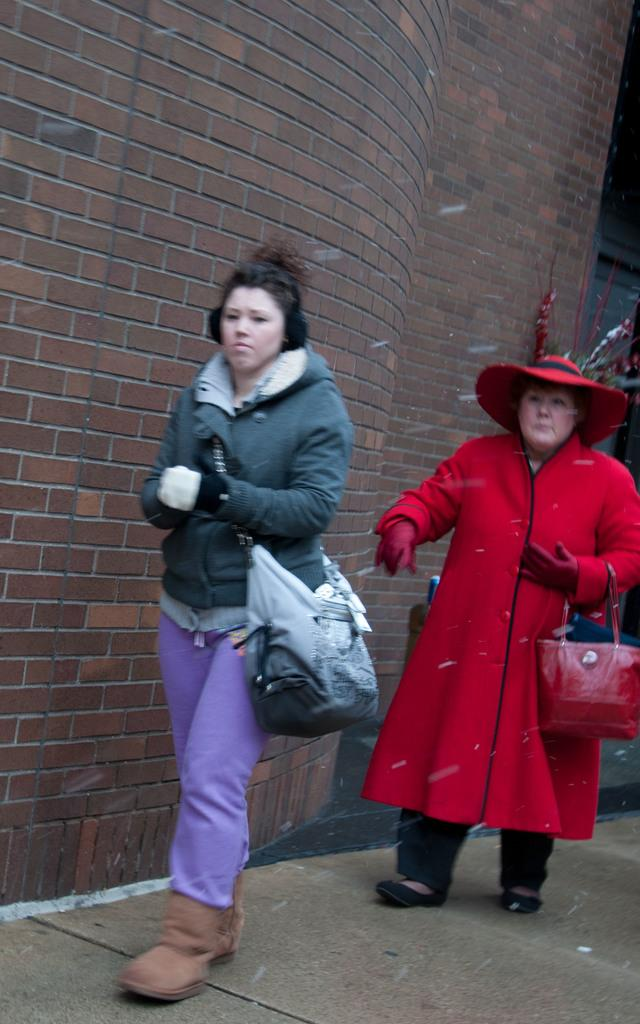How many women are in the image? There are two women in the image. What are the women doing in the image? The women are walking. What are the women carrying with them? The women are wearing handbags. What can be seen in the background of the image? There is a wall in the image. What is the wall made of? The wall is made of bricks. What type of furniture can be seen in the image? There is no furniture present in the image. Can you describe the crow that is perched on the wall in the image? There is no crow present in the image. 